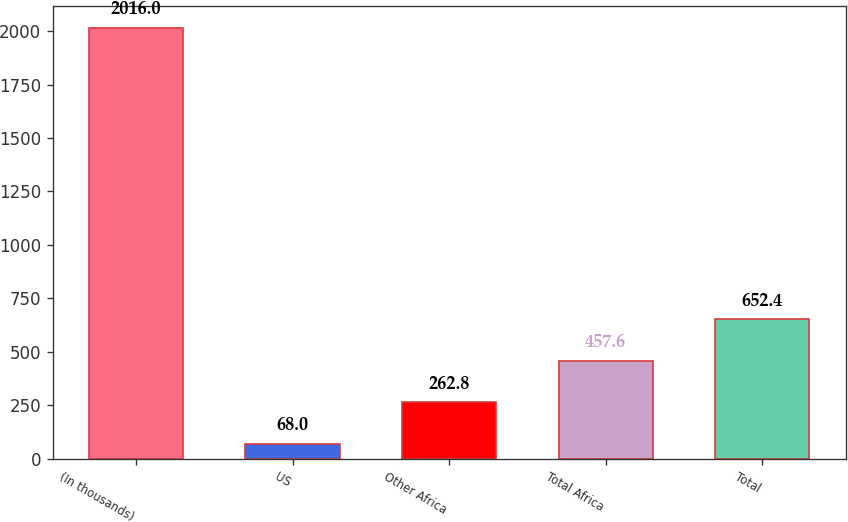Convert chart to OTSL. <chart><loc_0><loc_0><loc_500><loc_500><bar_chart><fcel>(In thousands)<fcel>US<fcel>Other Africa<fcel>Total Africa<fcel>Total<nl><fcel>2016<fcel>68<fcel>262.8<fcel>457.6<fcel>652.4<nl></chart> 